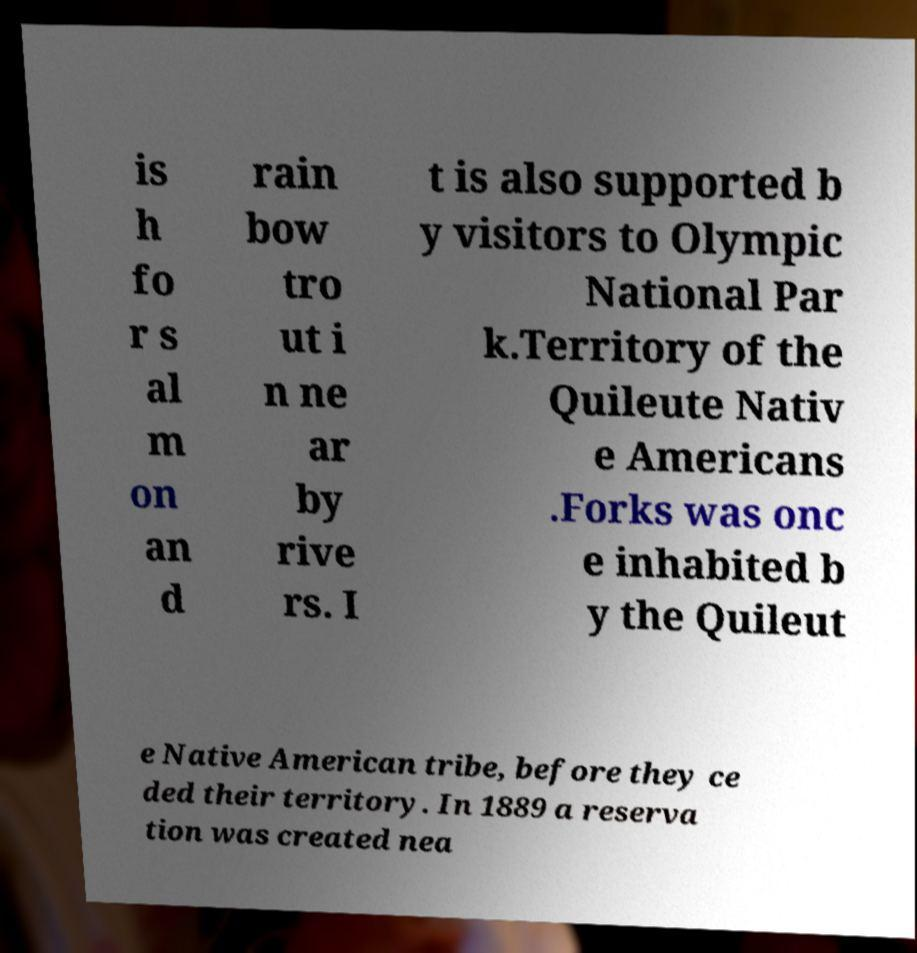Could you assist in decoding the text presented in this image and type it out clearly? is h fo r s al m on an d rain bow tro ut i n ne ar by rive rs. I t is also supported b y visitors to Olympic National Par k.Territory of the Quileute Nativ e Americans .Forks was onc e inhabited b y the Quileut e Native American tribe, before they ce ded their territory. In 1889 a reserva tion was created nea 